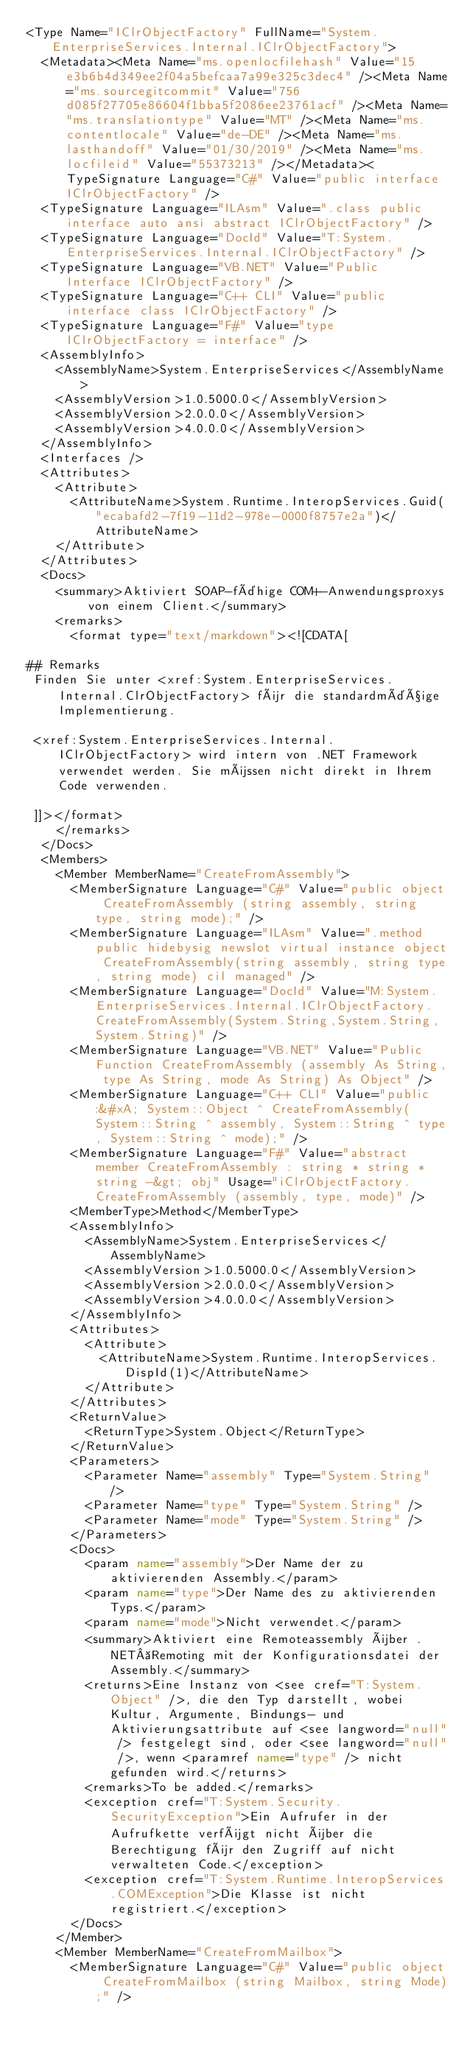Convert code to text. <code><loc_0><loc_0><loc_500><loc_500><_XML_><Type Name="IClrObjectFactory" FullName="System.EnterpriseServices.Internal.IClrObjectFactory">
  <Metadata><Meta Name="ms.openlocfilehash" Value="15e3b6b4d349ee2f04a5befcaa7a99e325c3dec4" /><Meta Name="ms.sourcegitcommit" Value="756d085f27705e86604f1bba5f2086ee23761acf" /><Meta Name="ms.translationtype" Value="MT" /><Meta Name="ms.contentlocale" Value="de-DE" /><Meta Name="ms.lasthandoff" Value="01/30/2019" /><Meta Name="ms.locfileid" Value="55373213" /></Metadata><TypeSignature Language="C#" Value="public interface IClrObjectFactory" />
  <TypeSignature Language="ILAsm" Value=".class public interface auto ansi abstract IClrObjectFactory" />
  <TypeSignature Language="DocId" Value="T:System.EnterpriseServices.Internal.IClrObjectFactory" />
  <TypeSignature Language="VB.NET" Value="Public Interface IClrObjectFactory" />
  <TypeSignature Language="C++ CLI" Value="public interface class IClrObjectFactory" />
  <TypeSignature Language="F#" Value="type IClrObjectFactory = interface" />
  <AssemblyInfo>
    <AssemblyName>System.EnterpriseServices</AssemblyName>
    <AssemblyVersion>1.0.5000.0</AssemblyVersion>
    <AssemblyVersion>2.0.0.0</AssemblyVersion>
    <AssemblyVersion>4.0.0.0</AssemblyVersion>
  </AssemblyInfo>
  <Interfaces />
  <Attributes>
    <Attribute>
      <AttributeName>System.Runtime.InteropServices.Guid("ecabafd2-7f19-11d2-978e-0000f8757e2a")</AttributeName>
    </Attribute>
  </Attributes>
  <Docs>
    <summary>Aktiviert SOAP-fähige COM+-Anwendungsproxys von einem Client.</summary>
    <remarks>
      <format type="text/markdown"><![CDATA[  
  
## Remarks  
 Finden Sie unter <xref:System.EnterpriseServices.Internal.ClrObjectFactory> für die standardmäßige Implementierung.  
  
 <xref:System.EnterpriseServices.Internal.IClrObjectFactory> wird intern von .NET Framework verwendet werden. Sie müssen nicht direkt in Ihrem Code verwenden.  
  
 ]]></format>
    </remarks>
  </Docs>
  <Members>
    <Member MemberName="CreateFromAssembly">
      <MemberSignature Language="C#" Value="public object CreateFromAssembly (string assembly, string type, string mode);" />
      <MemberSignature Language="ILAsm" Value=".method public hidebysig newslot virtual instance object CreateFromAssembly(string assembly, string type, string mode) cil managed" />
      <MemberSignature Language="DocId" Value="M:System.EnterpriseServices.Internal.IClrObjectFactory.CreateFromAssembly(System.String,System.String,System.String)" />
      <MemberSignature Language="VB.NET" Value="Public Function CreateFromAssembly (assembly As String, type As String, mode As String) As Object" />
      <MemberSignature Language="C++ CLI" Value="public:&#xA; System::Object ^ CreateFromAssembly(System::String ^ assembly, System::String ^ type, System::String ^ mode);" />
      <MemberSignature Language="F#" Value="abstract member CreateFromAssembly : string * string * string -&gt; obj" Usage="iClrObjectFactory.CreateFromAssembly (assembly, type, mode)" />
      <MemberType>Method</MemberType>
      <AssemblyInfo>
        <AssemblyName>System.EnterpriseServices</AssemblyName>
        <AssemblyVersion>1.0.5000.0</AssemblyVersion>
        <AssemblyVersion>2.0.0.0</AssemblyVersion>
        <AssemblyVersion>4.0.0.0</AssemblyVersion>
      </AssemblyInfo>
      <Attributes>
        <Attribute>
          <AttributeName>System.Runtime.InteropServices.DispId(1)</AttributeName>
        </Attribute>
      </Attributes>
      <ReturnValue>
        <ReturnType>System.Object</ReturnType>
      </ReturnValue>
      <Parameters>
        <Parameter Name="assembly" Type="System.String" />
        <Parameter Name="type" Type="System.String" />
        <Parameter Name="mode" Type="System.String" />
      </Parameters>
      <Docs>
        <param name="assembly">Der Name der zu aktivierenden Assembly.</param>
        <param name="type">Der Name des zu aktivierenden Typs.</param>
        <param name="mode">Nicht verwendet.</param>
        <summary>Aktiviert eine Remoteassembly über .NET Remoting mit der Konfigurationsdatei der Assembly.</summary>
        <returns>Eine Instanz von <see cref="T:System.Object" />, die den Typ darstellt, wobei Kultur, Argumente, Bindungs- und Aktivierungsattribute auf <see langword="null" /> festgelegt sind, oder <see langword="null" />, wenn <paramref name="type" /> nicht gefunden wird.</returns>
        <remarks>To be added.</remarks>
        <exception cref="T:System.Security.SecurityException">Ein Aufrufer in der Aufrufkette verfügt nicht über die Berechtigung für den Zugriff auf nicht verwalteten Code.</exception>
        <exception cref="T:System.Runtime.InteropServices.COMException">Die Klasse ist nicht registriert.</exception>
      </Docs>
    </Member>
    <Member MemberName="CreateFromMailbox">
      <MemberSignature Language="C#" Value="public object CreateFromMailbox (string Mailbox, string Mode);" /></code> 